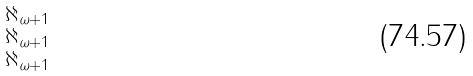Convert formula to latex. <formula><loc_0><loc_0><loc_500><loc_500>\begin{smallmatrix} \aleph _ { \omega + 1 } \\ \aleph _ { \omega + 1 } \\ \aleph _ { \omega + 1 } \end{smallmatrix}</formula> 